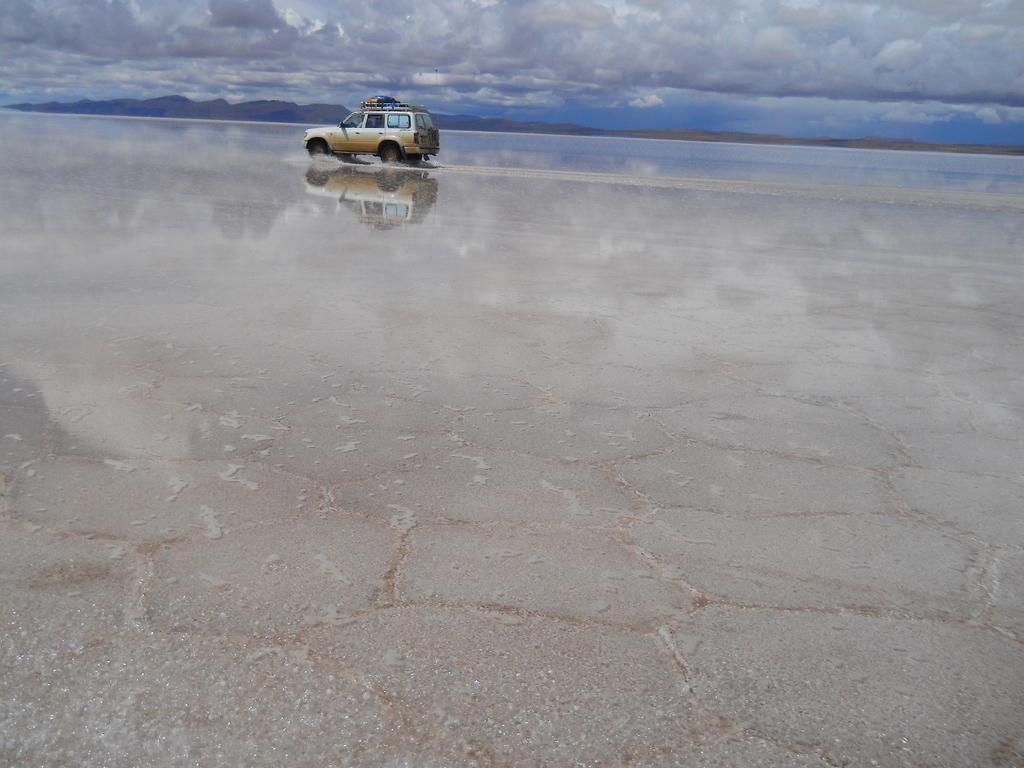How would you summarize this image in a sentence or two? In the picture I can see a vehicle moving on the road, here we can see the smoke, water, hills and the cloudy sky in the background. 